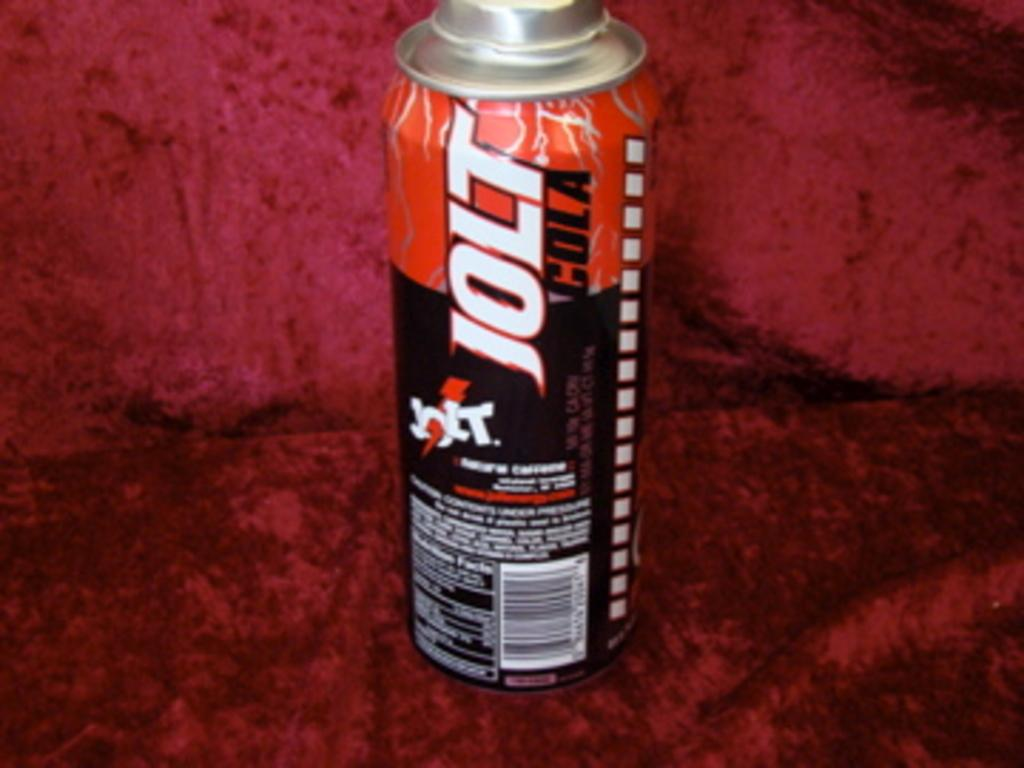<image>
Provide a brief description of the given image. A can of Jolt Cola sits on a burgundy backdrop. 